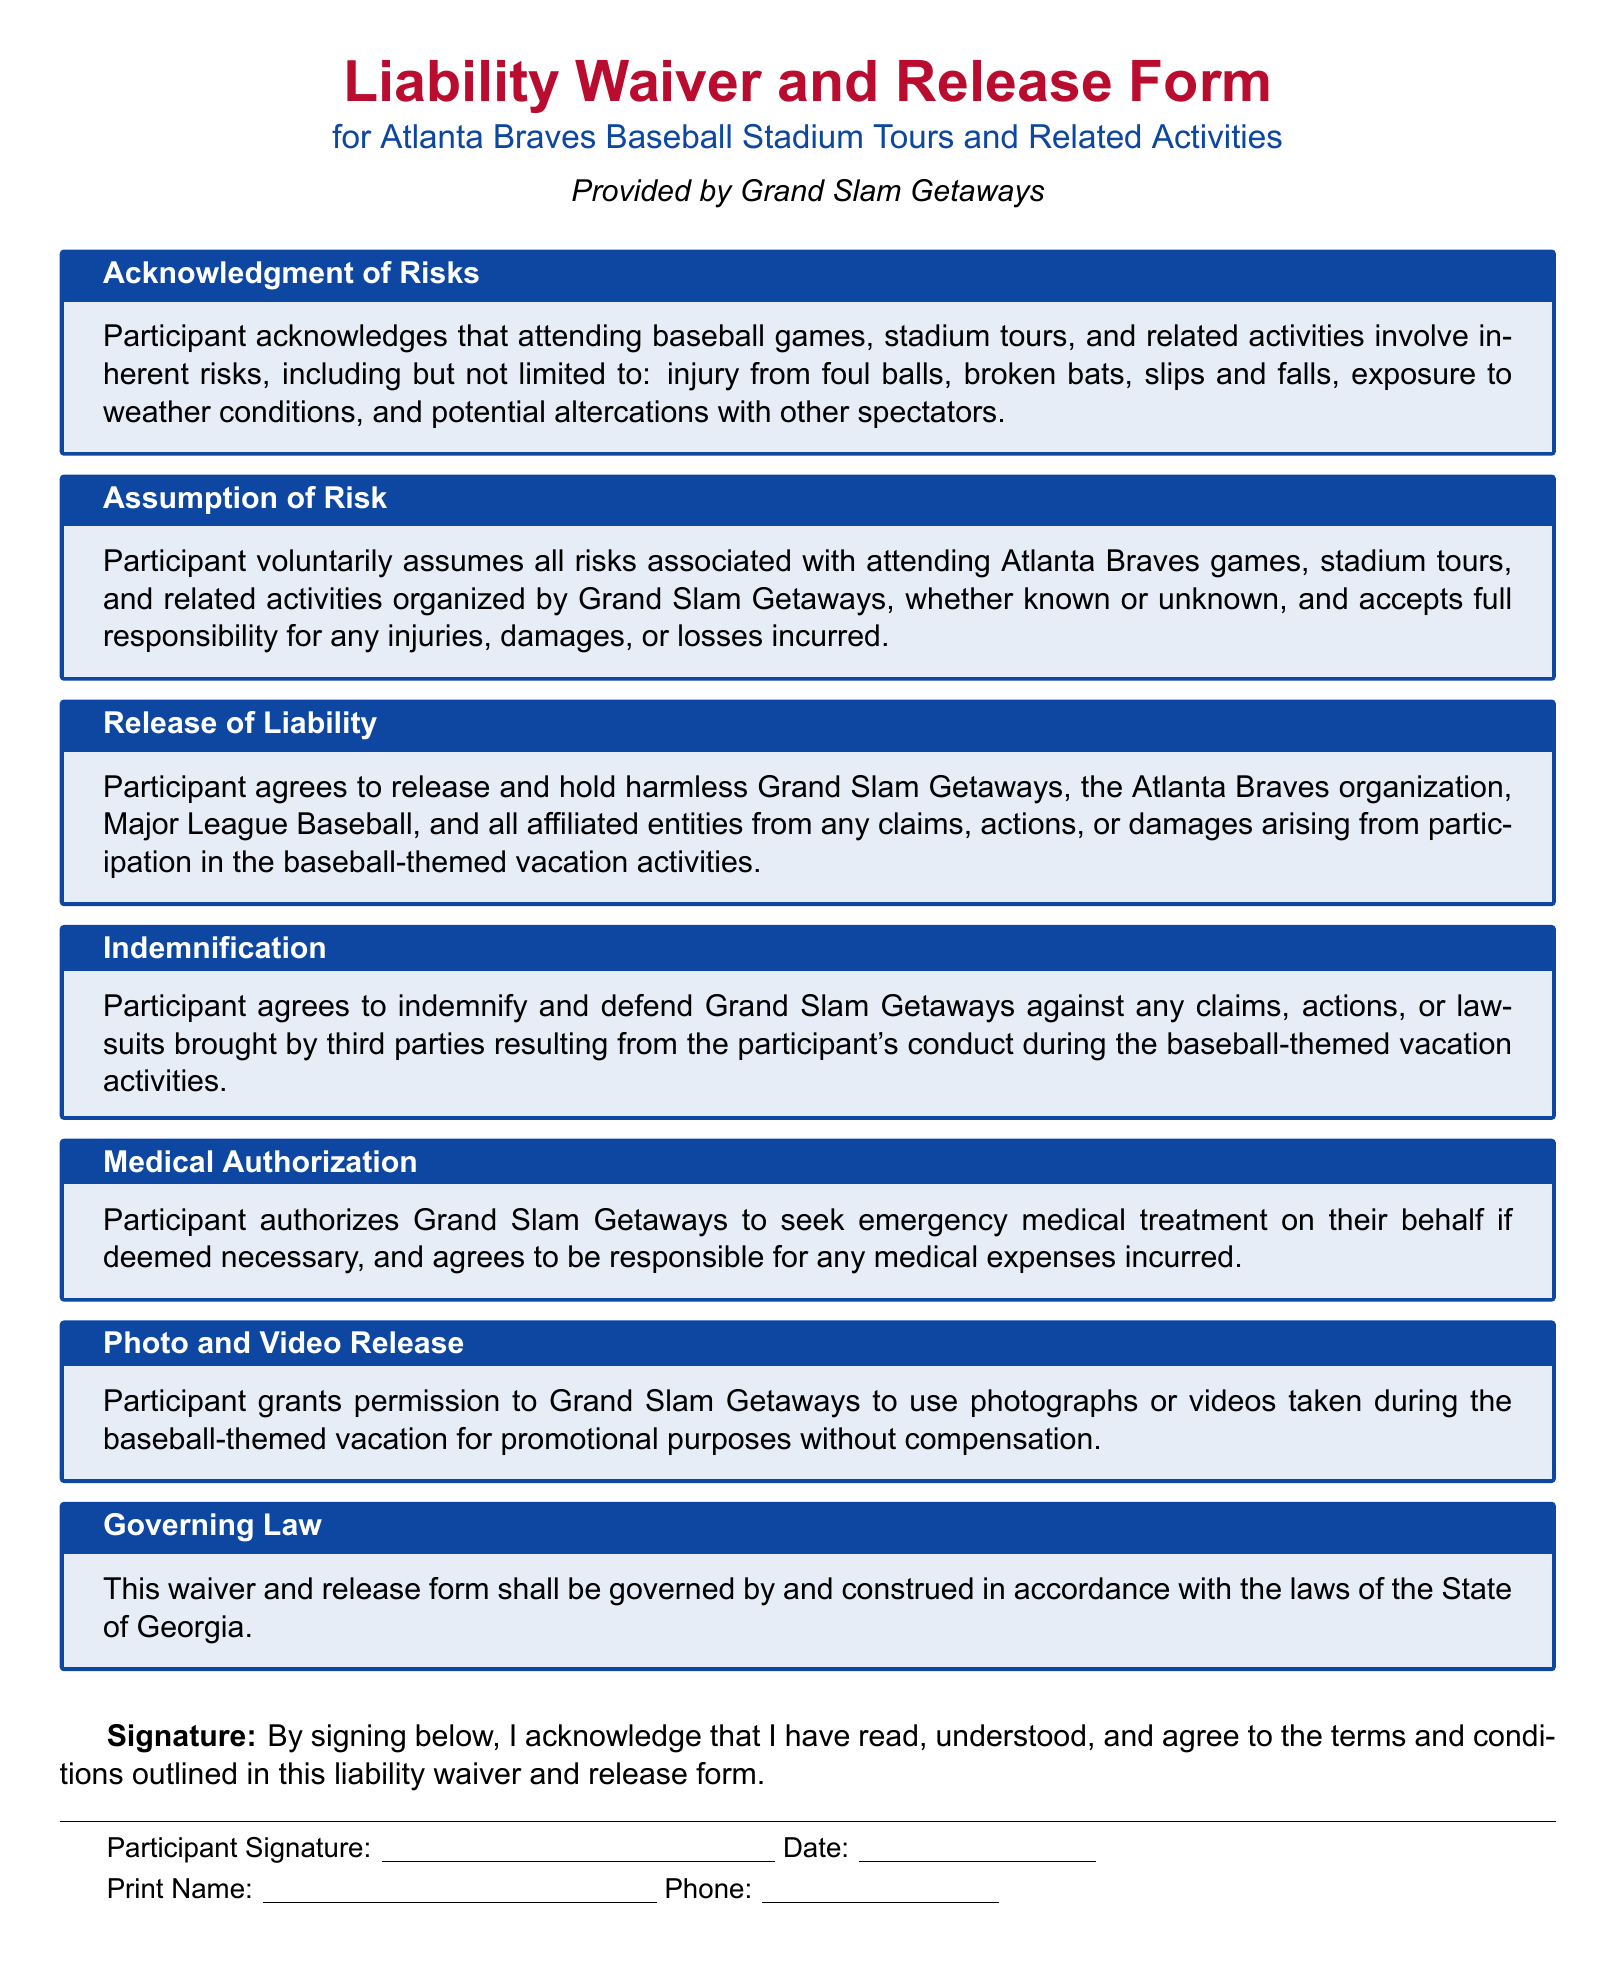What is the title of the document? The title is prominently displayed in the document, indicating the purpose and focus of the content.
Answer: Liability Waiver and Release Form Who provides the waiver? The document states who is responsible for this waiver, highlighting the organization behind it.
Answer: Grand Slam Getaways What risks are participants acknowledging? This section lists the types of risks that attendees may face, signaling the importance of understanding these risks before participation.
Answer: Injury from foul balls, broken bats, slips and falls, exposure to weather conditions, and potential altercations with other spectators What does the participant agree to in the release of liability? This section outlines the participant's agreement concerning legal claims, emphasizing the protection for the organizing bodies involved.
Answer: Release and hold harmless Grand Slam Getaways, the Atlanta Braves organization, Major League Baseball, and all affiliated entities Under what jurisdiction is the waiver governed? This indicates the legal framework applicable to the waiver, which is essential for legal interpretation and enforcement.
Answer: The State of Georgia What must participants authorize for medical treatment? This part of the document clarifies what participants consent to in case of a medical emergency, demonstrating an understanding of potential health needs.
Answer: Grand Slam Getaways to seek emergency medical treatment What is required from participants' before participating? This highlights the importance of participants asserting their understanding and acceptance of the waiver's conditions.
Answer: Signature What type of release do participants grant regarding photographs or videos? This question addresses the consent given by participants for the use of their images, which is important for marketing purposes.
Answer: Permission to use photographs or videos for promotional purposes without compensation 